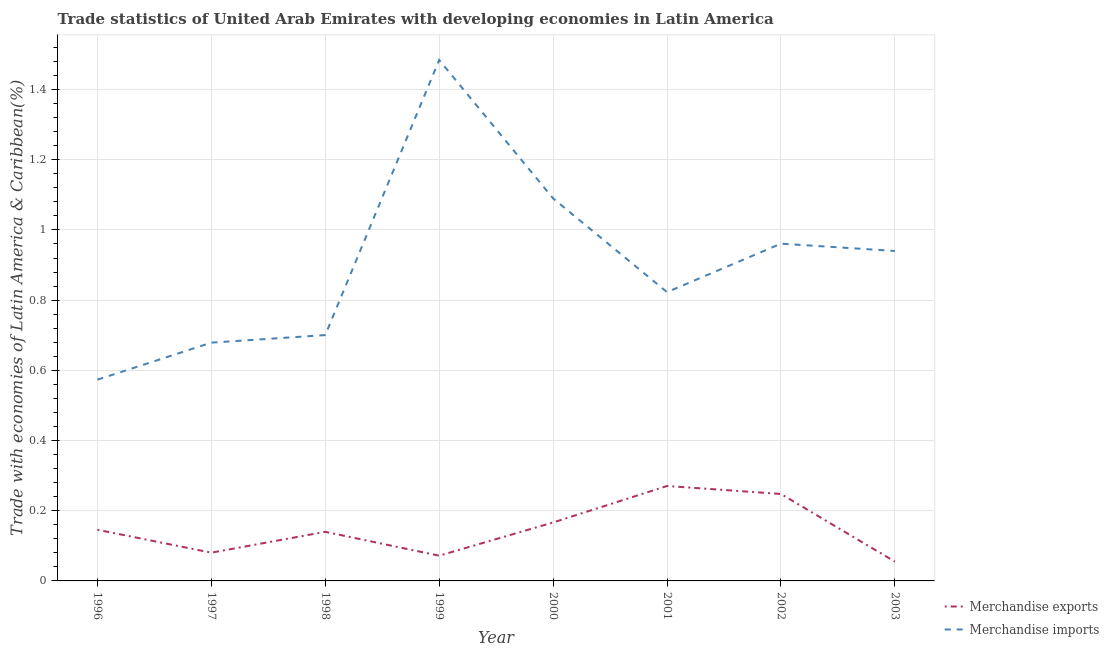How many different coloured lines are there?
Offer a very short reply. 2. Does the line corresponding to merchandise exports intersect with the line corresponding to merchandise imports?
Your answer should be compact. No. What is the merchandise imports in 1998?
Offer a very short reply. 0.7. Across all years, what is the maximum merchandise imports?
Provide a succinct answer. 1.48. Across all years, what is the minimum merchandise exports?
Make the answer very short. 0.06. What is the total merchandise imports in the graph?
Keep it short and to the point. 7.25. What is the difference between the merchandise exports in 1996 and that in 2000?
Provide a short and direct response. -0.02. What is the difference between the merchandise exports in 1997 and the merchandise imports in 2000?
Provide a short and direct response. -1.01. What is the average merchandise imports per year?
Provide a short and direct response. 0.91. In the year 1999, what is the difference between the merchandise exports and merchandise imports?
Your answer should be very brief. -1.41. In how many years, is the merchandise exports greater than 0.48000000000000004 %?
Your answer should be very brief. 0. What is the ratio of the merchandise exports in 1997 to that in 2001?
Your answer should be very brief. 0.3. Is the difference between the merchandise imports in 1997 and 2002 greater than the difference between the merchandise exports in 1997 and 2002?
Provide a succinct answer. No. What is the difference between the highest and the second highest merchandise imports?
Make the answer very short. 0.39. What is the difference between the highest and the lowest merchandise exports?
Provide a short and direct response. 0.22. In how many years, is the merchandise exports greater than the average merchandise exports taken over all years?
Keep it short and to the point. 3. What is the difference between two consecutive major ticks on the Y-axis?
Your response must be concise. 0.2. Where does the legend appear in the graph?
Make the answer very short. Bottom right. How are the legend labels stacked?
Provide a succinct answer. Vertical. What is the title of the graph?
Make the answer very short. Trade statistics of United Arab Emirates with developing economies in Latin America. Does "Nonresident" appear as one of the legend labels in the graph?
Your answer should be very brief. No. What is the label or title of the X-axis?
Make the answer very short. Year. What is the label or title of the Y-axis?
Provide a succinct answer. Trade with economies of Latin America & Caribbean(%). What is the Trade with economies of Latin America & Caribbean(%) of Merchandise exports in 1996?
Ensure brevity in your answer.  0.15. What is the Trade with economies of Latin America & Caribbean(%) in Merchandise imports in 1996?
Keep it short and to the point. 0.57. What is the Trade with economies of Latin America & Caribbean(%) of Merchandise exports in 1997?
Make the answer very short. 0.08. What is the Trade with economies of Latin America & Caribbean(%) in Merchandise imports in 1997?
Your answer should be compact. 0.68. What is the Trade with economies of Latin America & Caribbean(%) of Merchandise exports in 1998?
Ensure brevity in your answer.  0.14. What is the Trade with economies of Latin America & Caribbean(%) in Merchandise imports in 1998?
Make the answer very short. 0.7. What is the Trade with economies of Latin America & Caribbean(%) in Merchandise exports in 1999?
Your response must be concise. 0.07. What is the Trade with economies of Latin America & Caribbean(%) in Merchandise imports in 1999?
Your response must be concise. 1.48. What is the Trade with economies of Latin America & Caribbean(%) in Merchandise exports in 2000?
Ensure brevity in your answer.  0.17. What is the Trade with economies of Latin America & Caribbean(%) in Merchandise imports in 2000?
Keep it short and to the point. 1.09. What is the Trade with economies of Latin America & Caribbean(%) in Merchandise exports in 2001?
Your answer should be compact. 0.27. What is the Trade with economies of Latin America & Caribbean(%) of Merchandise imports in 2001?
Your answer should be very brief. 0.82. What is the Trade with economies of Latin America & Caribbean(%) of Merchandise exports in 2002?
Provide a succinct answer. 0.25. What is the Trade with economies of Latin America & Caribbean(%) in Merchandise imports in 2002?
Provide a succinct answer. 0.96. What is the Trade with economies of Latin America & Caribbean(%) in Merchandise exports in 2003?
Your answer should be compact. 0.06. What is the Trade with economies of Latin America & Caribbean(%) of Merchandise imports in 2003?
Give a very brief answer. 0.94. Across all years, what is the maximum Trade with economies of Latin America & Caribbean(%) in Merchandise exports?
Make the answer very short. 0.27. Across all years, what is the maximum Trade with economies of Latin America & Caribbean(%) of Merchandise imports?
Your response must be concise. 1.48. Across all years, what is the minimum Trade with economies of Latin America & Caribbean(%) in Merchandise exports?
Ensure brevity in your answer.  0.06. Across all years, what is the minimum Trade with economies of Latin America & Caribbean(%) in Merchandise imports?
Ensure brevity in your answer.  0.57. What is the total Trade with economies of Latin America & Caribbean(%) in Merchandise exports in the graph?
Keep it short and to the point. 1.18. What is the total Trade with economies of Latin America & Caribbean(%) of Merchandise imports in the graph?
Give a very brief answer. 7.25. What is the difference between the Trade with economies of Latin America & Caribbean(%) in Merchandise exports in 1996 and that in 1997?
Make the answer very short. 0.07. What is the difference between the Trade with economies of Latin America & Caribbean(%) in Merchandise imports in 1996 and that in 1997?
Keep it short and to the point. -0.11. What is the difference between the Trade with economies of Latin America & Caribbean(%) in Merchandise exports in 1996 and that in 1998?
Make the answer very short. 0.01. What is the difference between the Trade with economies of Latin America & Caribbean(%) of Merchandise imports in 1996 and that in 1998?
Provide a short and direct response. -0.13. What is the difference between the Trade with economies of Latin America & Caribbean(%) of Merchandise exports in 1996 and that in 1999?
Your response must be concise. 0.07. What is the difference between the Trade with economies of Latin America & Caribbean(%) of Merchandise imports in 1996 and that in 1999?
Keep it short and to the point. -0.91. What is the difference between the Trade with economies of Latin America & Caribbean(%) in Merchandise exports in 1996 and that in 2000?
Offer a terse response. -0.02. What is the difference between the Trade with economies of Latin America & Caribbean(%) of Merchandise imports in 1996 and that in 2000?
Give a very brief answer. -0.52. What is the difference between the Trade with economies of Latin America & Caribbean(%) of Merchandise exports in 1996 and that in 2001?
Offer a very short reply. -0.12. What is the difference between the Trade with economies of Latin America & Caribbean(%) in Merchandise imports in 1996 and that in 2001?
Your response must be concise. -0.25. What is the difference between the Trade with economies of Latin America & Caribbean(%) of Merchandise exports in 1996 and that in 2002?
Keep it short and to the point. -0.1. What is the difference between the Trade with economies of Latin America & Caribbean(%) in Merchandise imports in 1996 and that in 2002?
Offer a terse response. -0.39. What is the difference between the Trade with economies of Latin America & Caribbean(%) in Merchandise exports in 1996 and that in 2003?
Give a very brief answer. 0.09. What is the difference between the Trade with economies of Latin America & Caribbean(%) of Merchandise imports in 1996 and that in 2003?
Your answer should be very brief. -0.37. What is the difference between the Trade with economies of Latin America & Caribbean(%) of Merchandise exports in 1997 and that in 1998?
Your answer should be very brief. -0.06. What is the difference between the Trade with economies of Latin America & Caribbean(%) in Merchandise imports in 1997 and that in 1998?
Provide a short and direct response. -0.02. What is the difference between the Trade with economies of Latin America & Caribbean(%) in Merchandise exports in 1997 and that in 1999?
Ensure brevity in your answer.  0.01. What is the difference between the Trade with economies of Latin America & Caribbean(%) of Merchandise imports in 1997 and that in 1999?
Make the answer very short. -0.81. What is the difference between the Trade with economies of Latin America & Caribbean(%) of Merchandise exports in 1997 and that in 2000?
Make the answer very short. -0.09. What is the difference between the Trade with economies of Latin America & Caribbean(%) of Merchandise imports in 1997 and that in 2000?
Give a very brief answer. -0.41. What is the difference between the Trade with economies of Latin America & Caribbean(%) in Merchandise exports in 1997 and that in 2001?
Your response must be concise. -0.19. What is the difference between the Trade with economies of Latin America & Caribbean(%) of Merchandise imports in 1997 and that in 2001?
Offer a terse response. -0.14. What is the difference between the Trade with economies of Latin America & Caribbean(%) of Merchandise exports in 1997 and that in 2002?
Your response must be concise. -0.17. What is the difference between the Trade with economies of Latin America & Caribbean(%) in Merchandise imports in 1997 and that in 2002?
Your answer should be very brief. -0.28. What is the difference between the Trade with economies of Latin America & Caribbean(%) in Merchandise exports in 1997 and that in 2003?
Your response must be concise. 0.03. What is the difference between the Trade with economies of Latin America & Caribbean(%) of Merchandise imports in 1997 and that in 2003?
Your response must be concise. -0.26. What is the difference between the Trade with economies of Latin America & Caribbean(%) in Merchandise exports in 1998 and that in 1999?
Keep it short and to the point. 0.07. What is the difference between the Trade with economies of Latin America & Caribbean(%) in Merchandise imports in 1998 and that in 1999?
Provide a succinct answer. -0.78. What is the difference between the Trade with economies of Latin America & Caribbean(%) in Merchandise exports in 1998 and that in 2000?
Offer a terse response. -0.03. What is the difference between the Trade with economies of Latin America & Caribbean(%) in Merchandise imports in 1998 and that in 2000?
Your response must be concise. -0.39. What is the difference between the Trade with economies of Latin America & Caribbean(%) of Merchandise exports in 1998 and that in 2001?
Provide a short and direct response. -0.13. What is the difference between the Trade with economies of Latin America & Caribbean(%) in Merchandise imports in 1998 and that in 2001?
Provide a short and direct response. -0.12. What is the difference between the Trade with economies of Latin America & Caribbean(%) in Merchandise exports in 1998 and that in 2002?
Offer a very short reply. -0.11. What is the difference between the Trade with economies of Latin America & Caribbean(%) in Merchandise imports in 1998 and that in 2002?
Offer a terse response. -0.26. What is the difference between the Trade with economies of Latin America & Caribbean(%) in Merchandise exports in 1998 and that in 2003?
Provide a succinct answer. 0.08. What is the difference between the Trade with economies of Latin America & Caribbean(%) in Merchandise imports in 1998 and that in 2003?
Your answer should be very brief. -0.24. What is the difference between the Trade with economies of Latin America & Caribbean(%) of Merchandise exports in 1999 and that in 2000?
Make the answer very short. -0.09. What is the difference between the Trade with economies of Latin America & Caribbean(%) in Merchandise imports in 1999 and that in 2000?
Your answer should be very brief. 0.39. What is the difference between the Trade with economies of Latin America & Caribbean(%) of Merchandise exports in 1999 and that in 2001?
Make the answer very short. -0.2. What is the difference between the Trade with economies of Latin America & Caribbean(%) in Merchandise imports in 1999 and that in 2001?
Offer a very short reply. 0.66. What is the difference between the Trade with economies of Latin America & Caribbean(%) of Merchandise exports in 1999 and that in 2002?
Offer a terse response. -0.18. What is the difference between the Trade with economies of Latin America & Caribbean(%) in Merchandise imports in 1999 and that in 2002?
Ensure brevity in your answer.  0.52. What is the difference between the Trade with economies of Latin America & Caribbean(%) of Merchandise exports in 1999 and that in 2003?
Make the answer very short. 0.02. What is the difference between the Trade with economies of Latin America & Caribbean(%) in Merchandise imports in 1999 and that in 2003?
Provide a short and direct response. 0.54. What is the difference between the Trade with economies of Latin America & Caribbean(%) in Merchandise exports in 2000 and that in 2001?
Ensure brevity in your answer.  -0.1. What is the difference between the Trade with economies of Latin America & Caribbean(%) of Merchandise imports in 2000 and that in 2001?
Offer a terse response. 0.27. What is the difference between the Trade with economies of Latin America & Caribbean(%) in Merchandise exports in 2000 and that in 2002?
Provide a succinct answer. -0.08. What is the difference between the Trade with economies of Latin America & Caribbean(%) in Merchandise imports in 2000 and that in 2002?
Ensure brevity in your answer.  0.13. What is the difference between the Trade with economies of Latin America & Caribbean(%) of Merchandise exports in 2000 and that in 2003?
Your answer should be compact. 0.11. What is the difference between the Trade with economies of Latin America & Caribbean(%) of Merchandise imports in 2000 and that in 2003?
Offer a terse response. 0.15. What is the difference between the Trade with economies of Latin America & Caribbean(%) of Merchandise exports in 2001 and that in 2002?
Make the answer very short. 0.02. What is the difference between the Trade with economies of Latin America & Caribbean(%) of Merchandise imports in 2001 and that in 2002?
Provide a succinct answer. -0.14. What is the difference between the Trade with economies of Latin America & Caribbean(%) in Merchandise exports in 2001 and that in 2003?
Your answer should be compact. 0.22. What is the difference between the Trade with economies of Latin America & Caribbean(%) of Merchandise imports in 2001 and that in 2003?
Make the answer very short. -0.12. What is the difference between the Trade with economies of Latin America & Caribbean(%) in Merchandise exports in 2002 and that in 2003?
Ensure brevity in your answer.  0.19. What is the difference between the Trade with economies of Latin America & Caribbean(%) of Merchandise imports in 2002 and that in 2003?
Make the answer very short. 0.02. What is the difference between the Trade with economies of Latin America & Caribbean(%) of Merchandise exports in 1996 and the Trade with economies of Latin America & Caribbean(%) of Merchandise imports in 1997?
Offer a terse response. -0.53. What is the difference between the Trade with economies of Latin America & Caribbean(%) in Merchandise exports in 1996 and the Trade with economies of Latin America & Caribbean(%) in Merchandise imports in 1998?
Offer a very short reply. -0.55. What is the difference between the Trade with economies of Latin America & Caribbean(%) in Merchandise exports in 1996 and the Trade with economies of Latin America & Caribbean(%) in Merchandise imports in 1999?
Your response must be concise. -1.34. What is the difference between the Trade with economies of Latin America & Caribbean(%) in Merchandise exports in 1996 and the Trade with economies of Latin America & Caribbean(%) in Merchandise imports in 2000?
Your answer should be very brief. -0.94. What is the difference between the Trade with economies of Latin America & Caribbean(%) in Merchandise exports in 1996 and the Trade with economies of Latin America & Caribbean(%) in Merchandise imports in 2001?
Give a very brief answer. -0.68. What is the difference between the Trade with economies of Latin America & Caribbean(%) in Merchandise exports in 1996 and the Trade with economies of Latin America & Caribbean(%) in Merchandise imports in 2002?
Make the answer very short. -0.82. What is the difference between the Trade with economies of Latin America & Caribbean(%) in Merchandise exports in 1996 and the Trade with economies of Latin America & Caribbean(%) in Merchandise imports in 2003?
Ensure brevity in your answer.  -0.79. What is the difference between the Trade with economies of Latin America & Caribbean(%) in Merchandise exports in 1997 and the Trade with economies of Latin America & Caribbean(%) in Merchandise imports in 1998?
Your answer should be compact. -0.62. What is the difference between the Trade with economies of Latin America & Caribbean(%) of Merchandise exports in 1997 and the Trade with economies of Latin America & Caribbean(%) of Merchandise imports in 1999?
Give a very brief answer. -1.4. What is the difference between the Trade with economies of Latin America & Caribbean(%) of Merchandise exports in 1997 and the Trade with economies of Latin America & Caribbean(%) of Merchandise imports in 2000?
Offer a terse response. -1.01. What is the difference between the Trade with economies of Latin America & Caribbean(%) of Merchandise exports in 1997 and the Trade with economies of Latin America & Caribbean(%) of Merchandise imports in 2001?
Ensure brevity in your answer.  -0.74. What is the difference between the Trade with economies of Latin America & Caribbean(%) of Merchandise exports in 1997 and the Trade with economies of Latin America & Caribbean(%) of Merchandise imports in 2002?
Offer a terse response. -0.88. What is the difference between the Trade with economies of Latin America & Caribbean(%) of Merchandise exports in 1997 and the Trade with economies of Latin America & Caribbean(%) of Merchandise imports in 2003?
Give a very brief answer. -0.86. What is the difference between the Trade with economies of Latin America & Caribbean(%) of Merchandise exports in 1998 and the Trade with economies of Latin America & Caribbean(%) of Merchandise imports in 1999?
Your answer should be very brief. -1.34. What is the difference between the Trade with economies of Latin America & Caribbean(%) in Merchandise exports in 1998 and the Trade with economies of Latin America & Caribbean(%) in Merchandise imports in 2000?
Offer a terse response. -0.95. What is the difference between the Trade with economies of Latin America & Caribbean(%) in Merchandise exports in 1998 and the Trade with economies of Latin America & Caribbean(%) in Merchandise imports in 2001?
Provide a short and direct response. -0.68. What is the difference between the Trade with economies of Latin America & Caribbean(%) of Merchandise exports in 1998 and the Trade with economies of Latin America & Caribbean(%) of Merchandise imports in 2002?
Give a very brief answer. -0.82. What is the difference between the Trade with economies of Latin America & Caribbean(%) of Merchandise exports in 1998 and the Trade with economies of Latin America & Caribbean(%) of Merchandise imports in 2003?
Your response must be concise. -0.8. What is the difference between the Trade with economies of Latin America & Caribbean(%) in Merchandise exports in 1999 and the Trade with economies of Latin America & Caribbean(%) in Merchandise imports in 2000?
Offer a very short reply. -1.02. What is the difference between the Trade with economies of Latin America & Caribbean(%) of Merchandise exports in 1999 and the Trade with economies of Latin America & Caribbean(%) of Merchandise imports in 2001?
Give a very brief answer. -0.75. What is the difference between the Trade with economies of Latin America & Caribbean(%) of Merchandise exports in 1999 and the Trade with economies of Latin America & Caribbean(%) of Merchandise imports in 2002?
Your answer should be compact. -0.89. What is the difference between the Trade with economies of Latin America & Caribbean(%) of Merchandise exports in 1999 and the Trade with economies of Latin America & Caribbean(%) of Merchandise imports in 2003?
Keep it short and to the point. -0.87. What is the difference between the Trade with economies of Latin America & Caribbean(%) of Merchandise exports in 2000 and the Trade with economies of Latin America & Caribbean(%) of Merchandise imports in 2001?
Offer a very short reply. -0.66. What is the difference between the Trade with economies of Latin America & Caribbean(%) in Merchandise exports in 2000 and the Trade with economies of Latin America & Caribbean(%) in Merchandise imports in 2002?
Keep it short and to the point. -0.79. What is the difference between the Trade with economies of Latin America & Caribbean(%) of Merchandise exports in 2000 and the Trade with economies of Latin America & Caribbean(%) of Merchandise imports in 2003?
Ensure brevity in your answer.  -0.77. What is the difference between the Trade with economies of Latin America & Caribbean(%) in Merchandise exports in 2001 and the Trade with economies of Latin America & Caribbean(%) in Merchandise imports in 2002?
Ensure brevity in your answer.  -0.69. What is the difference between the Trade with economies of Latin America & Caribbean(%) in Merchandise exports in 2001 and the Trade with economies of Latin America & Caribbean(%) in Merchandise imports in 2003?
Ensure brevity in your answer.  -0.67. What is the difference between the Trade with economies of Latin America & Caribbean(%) in Merchandise exports in 2002 and the Trade with economies of Latin America & Caribbean(%) in Merchandise imports in 2003?
Your answer should be compact. -0.69. What is the average Trade with economies of Latin America & Caribbean(%) in Merchandise exports per year?
Ensure brevity in your answer.  0.15. What is the average Trade with economies of Latin America & Caribbean(%) in Merchandise imports per year?
Offer a terse response. 0.91. In the year 1996, what is the difference between the Trade with economies of Latin America & Caribbean(%) of Merchandise exports and Trade with economies of Latin America & Caribbean(%) of Merchandise imports?
Offer a terse response. -0.43. In the year 1997, what is the difference between the Trade with economies of Latin America & Caribbean(%) in Merchandise exports and Trade with economies of Latin America & Caribbean(%) in Merchandise imports?
Offer a very short reply. -0.6. In the year 1998, what is the difference between the Trade with economies of Latin America & Caribbean(%) of Merchandise exports and Trade with economies of Latin America & Caribbean(%) of Merchandise imports?
Provide a succinct answer. -0.56. In the year 1999, what is the difference between the Trade with economies of Latin America & Caribbean(%) in Merchandise exports and Trade with economies of Latin America & Caribbean(%) in Merchandise imports?
Ensure brevity in your answer.  -1.41. In the year 2000, what is the difference between the Trade with economies of Latin America & Caribbean(%) in Merchandise exports and Trade with economies of Latin America & Caribbean(%) in Merchandise imports?
Your response must be concise. -0.92. In the year 2001, what is the difference between the Trade with economies of Latin America & Caribbean(%) in Merchandise exports and Trade with economies of Latin America & Caribbean(%) in Merchandise imports?
Your response must be concise. -0.55. In the year 2002, what is the difference between the Trade with economies of Latin America & Caribbean(%) of Merchandise exports and Trade with economies of Latin America & Caribbean(%) of Merchandise imports?
Keep it short and to the point. -0.71. In the year 2003, what is the difference between the Trade with economies of Latin America & Caribbean(%) in Merchandise exports and Trade with economies of Latin America & Caribbean(%) in Merchandise imports?
Provide a short and direct response. -0.89. What is the ratio of the Trade with economies of Latin America & Caribbean(%) of Merchandise exports in 1996 to that in 1997?
Keep it short and to the point. 1.81. What is the ratio of the Trade with economies of Latin America & Caribbean(%) in Merchandise imports in 1996 to that in 1997?
Provide a short and direct response. 0.84. What is the ratio of the Trade with economies of Latin America & Caribbean(%) of Merchandise exports in 1996 to that in 1998?
Make the answer very short. 1.04. What is the ratio of the Trade with economies of Latin America & Caribbean(%) of Merchandise imports in 1996 to that in 1998?
Your answer should be compact. 0.82. What is the ratio of the Trade with economies of Latin America & Caribbean(%) in Merchandise exports in 1996 to that in 1999?
Ensure brevity in your answer.  2.03. What is the ratio of the Trade with economies of Latin America & Caribbean(%) in Merchandise imports in 1996 to that in 1999?
Provide a short and direct response. 0.39. What is the ratio of the Trade with economies of Latin America & Caribbean(%) in Merchandise exports in 1996 to that in 2000?
Your response must be concise. 0.88. What is the ratio of the Trade with economies of Latin America & Caribbean(%) in Merchandise imports in 1996 to that in 2000?
Make the answer very short. 0.53. What is the ratio of the Trade with economies of Latin America & Caribbean(%) of Merchandise exports in 1996 to that in 2001?
Your answer should be very brief. 0.54. What is the ratio of the Trade with economies of Latin America & Caribbean(%) in Merchandise imports in 1996 to that in 2001?
Provide a short and direct response. 0.7. What is the ratio of the Trade with economies of Latin America & Caribbean(%) in Merchandise exports in 1996 to that in 2002?
Your answer should be compact. 0.59. What is the ratio of the Trade with economies of Latin America & Caribbean(%) of Merchandise imports in 1996 to that in 2002?
Offer a terse response. 0.6. What is the ratio of the Trade with economies of Latin America & Caribbean(%) in Merchandise exports in 1996 to that in 2003?
Offer a very short reply. 2.65. What is the ratio of the Trade with economies of Latin America & Caribbean(%) in Merchandise imports in 1996 to that in 2003?
Provide a succinct answer. 0.61. What is the ratio of the Trade with economies of Latin America & Caribbean(%) of Merchandise exports in 1997 to that in 1998?
Ensure brevity in your answer.  0.58. What is the ratio of the Trade with economies of Latin America & Caribbean(%) in Merchandise imports in 1997 to that in 1998?
Make the answer very short. 0.97. What is the ratio of the Trade with economies of Latin America & Caribbean(%) in Merchandise exports in 1997 to that in 1999?
Provide a short and direct response. 1.12. What is the ratio of the Trade with economies of Latin America & Caribbean(%) of Merchandise imports in 1997 to that in 1999?
Keep it short and to the point. 0.46. What is the ratio of the Trade with economies of Latin America & Caribbean(%) of Merchandise exports in 1997 to that in 2000?
Keep it short and to the point. 0.48. What is the ratio of the Trade with economies of Latin America & Caribbean(%) in Merchandise imports in 1997 to that in 2000?
Your response must be concise. 0.62. What is the ratio of the Trade with economies of Latin America & Caribbean(%) in Merchandise exports in 1997 to that in 2001?
Provide a succinct answer. 0.3. What is the ratio of the Trade with economies of Latin America & Caribbean(%) of Merchandise imports in 1997 to that in 2001?
Offer a terse response. 0.83. What is the ratio of the Trade with economies of Latin America & Caribbean(%) in Merchandise exports in 1997 to that in 2002?
Keep it short and to the point. 0.32. What is the ratio of the Trade with economies of Latin America & Caribbean(%) of Merchandise imports in 1997 to that in 2002?
Your answer should be compact. 0.71. What is the ratio of the Trade with economies of Latin America & Caribbean(%) of Merchandise exports in 1997 to that in 2003?
Your answer should be compact. 1.46. What is the ratio of the Trade with economies of Latin America & Caribbean(%) in Merchandise imports in 1997 to that in 2003?
Keep it short and to the point. 0.72. What is the ratio of the Trade with economies of Latin America & Caribbean(%) in Merchandise exports in 1998 to that in 1999?
Provide a short and direct response. 1.95. What is the ratio of the Trade with economies of Latin America & Caribbean(%) in Merchandise imports in 1998 to that in 1999?
Offer a terse response. 0.47. What is the ratio of the Trade with economies of Latin America & Caribbean(%) in Merchandise exports in 1998 to that in 2000?
Your answer should be compact. 0.84. What is the ratio of the Trade with economies of Latin America & Caribbean(%) of Merchandise imports in 1998 to that in 2000?
Offer a very short reply. 0.64. What is the ratio of the Trade with economies of Latin America & Caribbean(%) of Merchandise exports in 1998 to that in 2001?
Your answer should be very brief. 0.52. What is the ratio of the Trade with economies of Latin America & Caribbean(%) in Merchandise imports in 1998 to that in 2001?
Your answer should be compact. 0.85. What is the ratio of the Trade with economies of Latin America & Caribbean(%) of Merchandise exports in 1998 to that in 2002?
Your answer should be compact. 0.56. What is the ratio of the Trade with economies of Latin America & Caribbean(%) in Merchandise imports in 1998 to that in 2002?
Provide a succinct answer. 0.73. What is the ratio of the Trade with economies of Latin America & Caribbean(%) of Merchandise exports in 1998 to that in 2003?
Offer a very short reply. 2.54. What is the ratio of the Trade with economies of Latin America & Caribbean(%) of Merchandise imports in 1998 to that in 2003?
Your answer should be compact. 0.75. What is the ratio of the Trade with economies of Latin America & Caribbean(%) in Merchandise exports in 1999 to that in 2000?
Ensure brevity in your answer.  0.43. What is the ratio of the Trade with economies of Latin America & Caribbean(%) in Merchandise imports in 1999 to that in 2000?
Your answer should be very brief. 1.36. What is the ratio of the Trade with economies of Latin America & Caribbean(%) of Merchandise exports in 1999 to that in 2001?
Provide a succinct answer. 0.27. What is the ratio of the Trade with economies of Latin America & Caribbean(%) of Merchandise imports in 1999 to that in 2001?
Ensure brevity in your answer.  1.8. What is the ratio of the Trade with economies of Latin America & Caribbean(%) of Merchandise exports in 1999 to that in 2002?
Make the answer very short. 0.29. What is the ratio of the Trade with economies of Latin America & Caribbean(%) in Merchandise imports in 1999 to that in 2002?
Give a very brief answer. 1.54. What is the ratio of the Trade with economies of Latin America & Caribbean(%) in Merchandise exports in 1999 to that in 2003?
Offer a very short reply. 1.31. What is the ratio of the Trade with economies of Latin America & Caribbean(%) of Merchandise imports in 1999 to that in 2003?
Offer a terse response. 1.58. What is the ratio of the Trade with economies of Latin America & Caribbean(%) of Merchandise exports in 2000 to that in 2001?
Offer a terse response. 0.62. What is the ratio of the Trade with economies of Latin America & Caribbean(%) in Merchandise imports in 2000 to that in 2001?
Your answer should be compact. 1.32. What is the ratio of the Trade with economies of Latin America & Caribbean(%) in Merchandise exports in 2000 to that in 2002?
Your response must be concise. 0.67. What is the ratio of the Trade with economies of Latin America & Caribbean(%) of Merchandise imports in 2000 to that in 2002?
Provide a short and direct response. 1.13. What is the ratio of the Trade with economies of Latin America & Caribbean(%) of Merchandise exports in 2000 to that in 2003?
Give a very brief answer. 3.02. What is the ratio of the Trade with economies of Latin America & Caribbean(%) in Merchandise imports in 2000 to that in 2003?
Keep it short and to the point. 1.16. What is the ratio of the Trade with economies of Latin America & Caribbean(%) in Merchandise exports in 2001 to that in 2002?
Keep it short and to the point. 1.09. What is the ratio of the Trade with economies of Latin America & Caribbean(%) in Merchandise imports in 2001 to that in 2002?
Keep it short and to the point. 0.86. What is the ratio of the Trade with economies of Latin America & Caribbean(%) in Merchandise exports in 2001 to that in 2003?
Keep it short and to the point. 4.91. What is the ratio of the Trade with economies of Latin America & Caribbean(%) of Merchandise imports in 2001 to that in 2003?
Offer a terse response. 0.88. What is the ratio of the Trade with economies of Latin America & Caribbean(%) of Merchandise exports in 2002 to that in 2003?
Provide a short and direct response. 4.5. What is the ratio of the Trade with economies of Latin America & Caribbean(%) of Merchandise imports in 2002 to that in 2003?
Give a very brief answer. 1.02. What is the difference between the highest and the second highest Trade with economies of Latin America & Caribbean(%) of Merchandise exports?
Your response must be concise. 0.02. What is the difference between the highest and the second highest Trade with economies of Latin America & Caribbean(%) of Merchandise imports?
Provide a short and direct response. 0.39. What is the difference between the highest and the lowest Trade with economies of Latin America & Caribbean(%) in Merchandise exports?
Ensure brevity in your answer.  0.22. What is the difference between the highest and the lowest Trade with economies of Latin America & Caribbean(%) in Merchandise imports?
Provide a short and direct response. 0.91. 